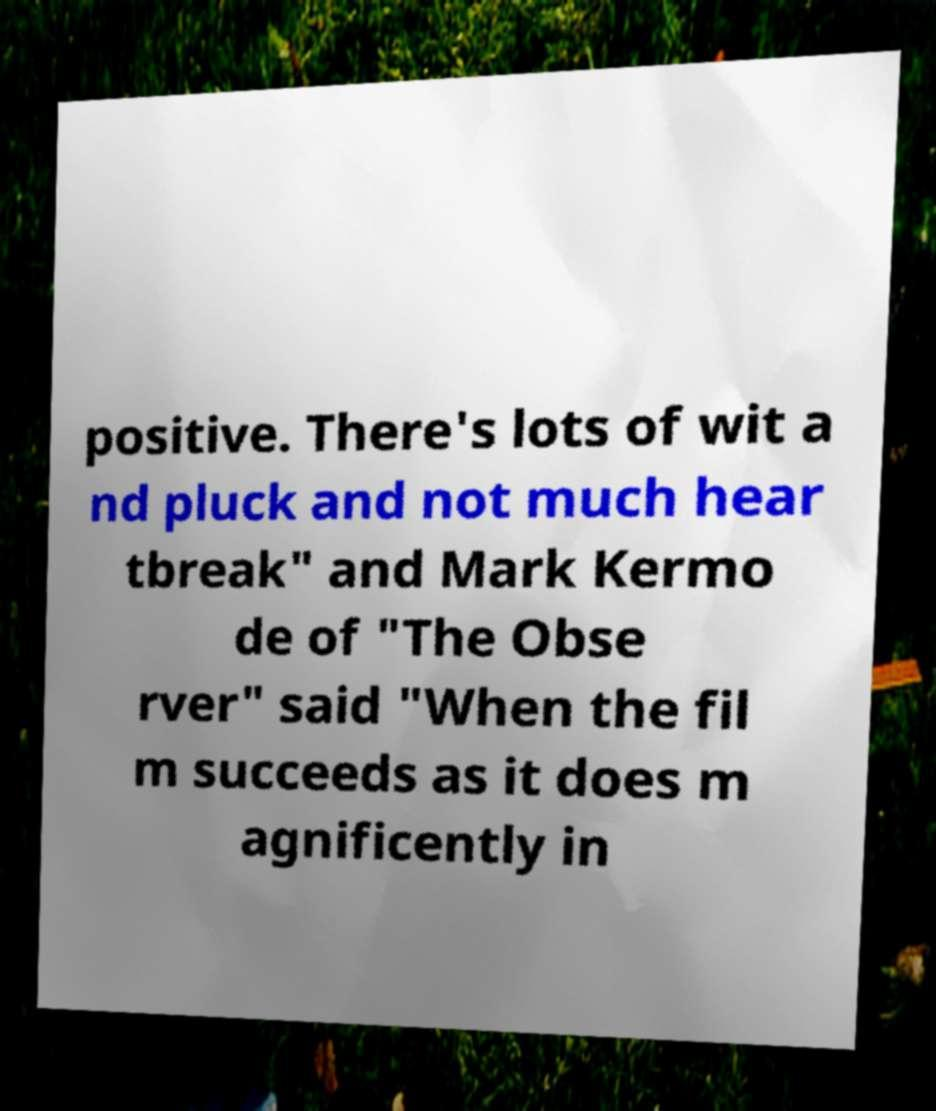Could you extract and type out the text from this image? positive. There's lots of wit a nd pluck and not much hear tbreak" and Mark Kermo de of "The Obse rver" said "When the fil m succeeds as it does m agnificently in 